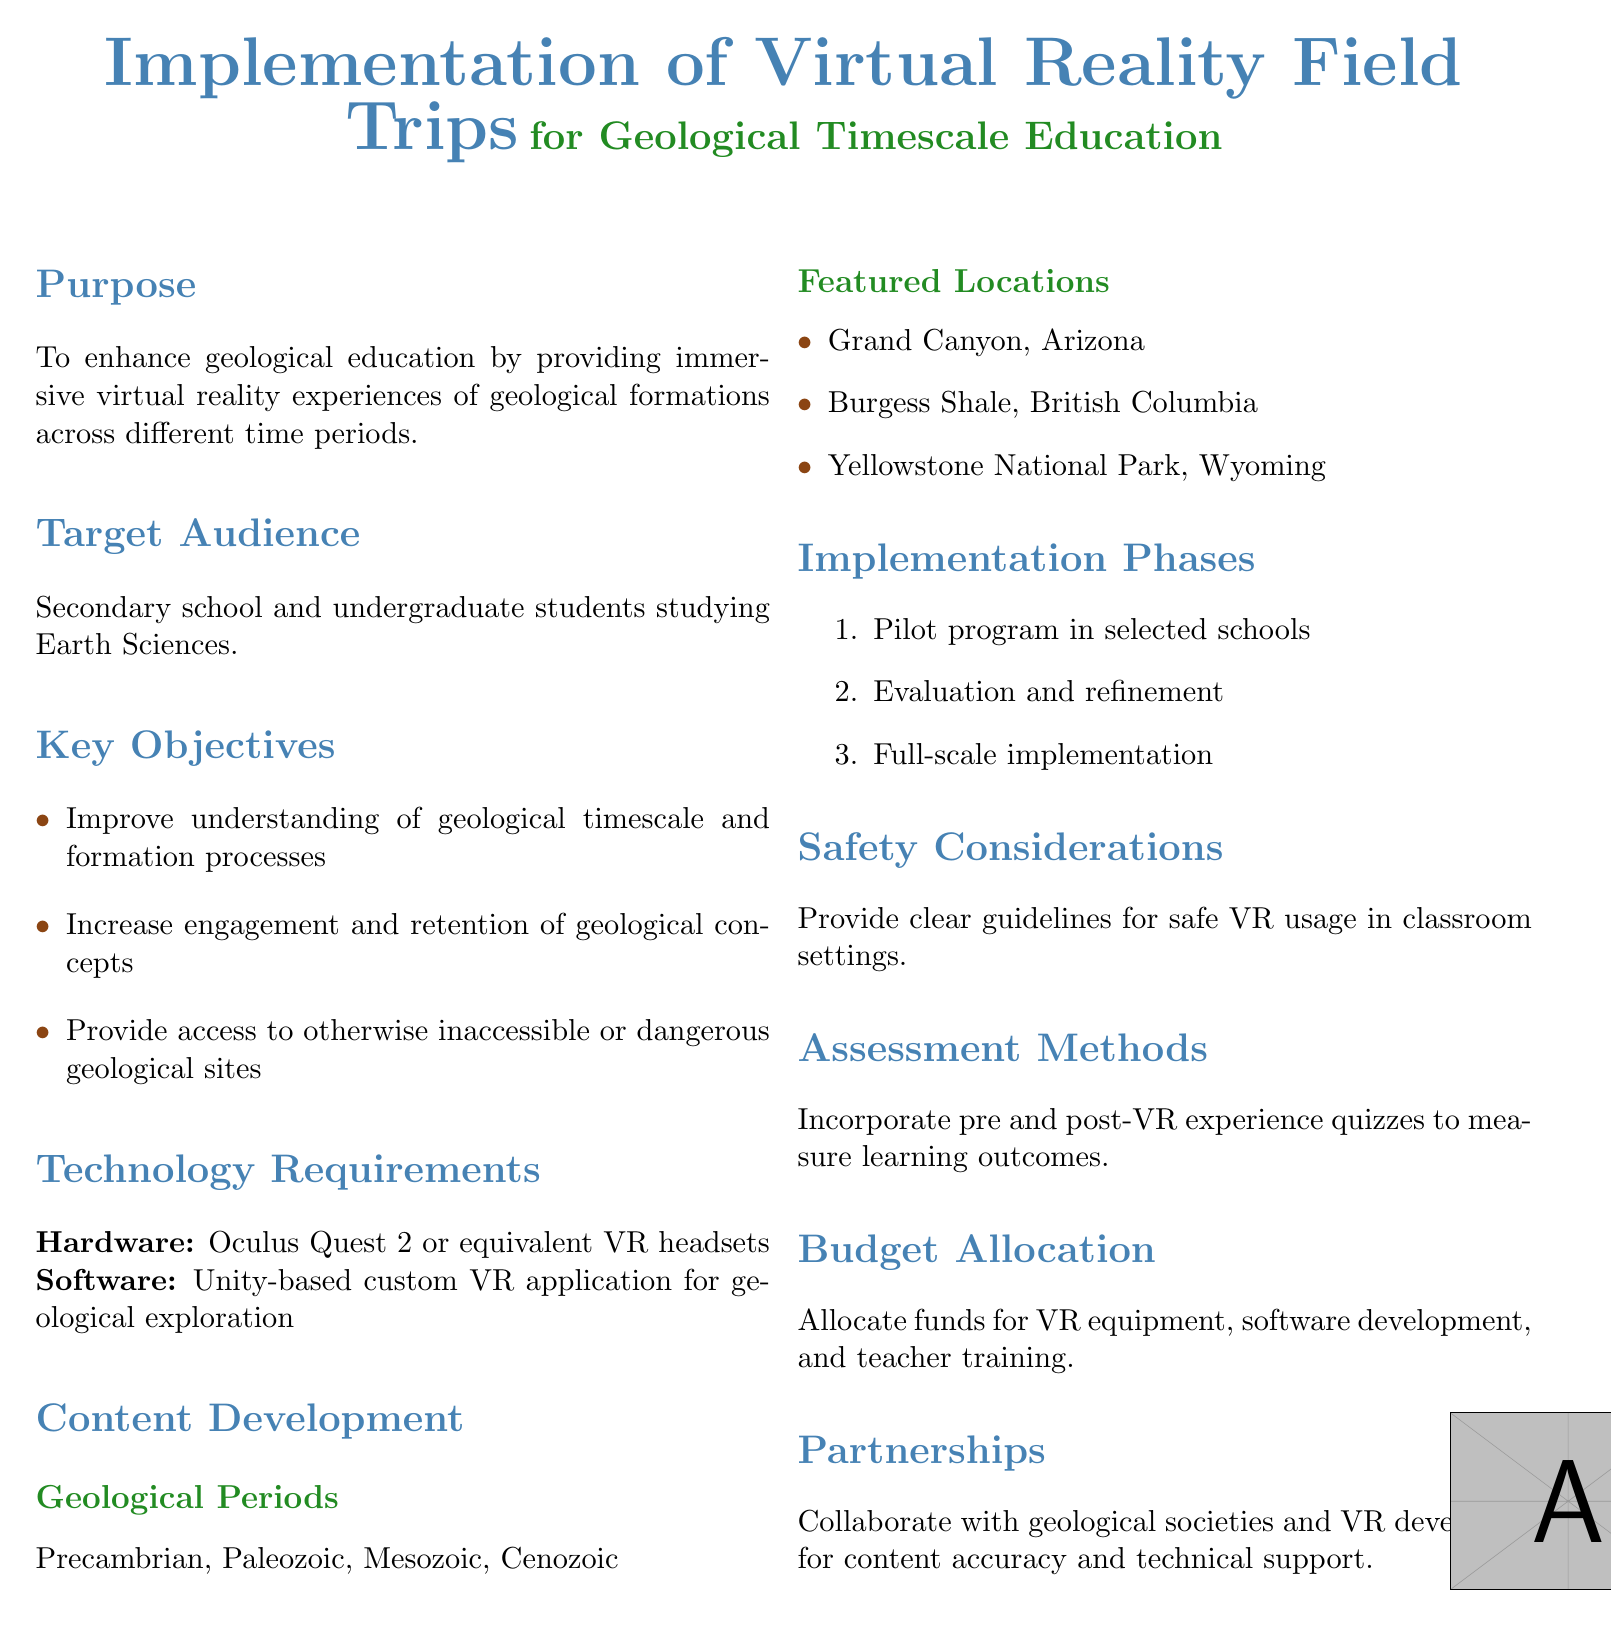What is the main purpose of the document? The main purpose is to enhance geological education through immersive experiences.
Answer: Enhance geological education Who is the target audience for this policy? The target audience is specified as secondary school and undergraduate students studying Earth Sciences.
Answer: Secondary school and undergraduate students What are the key objectives of this initiative? The key objectives include improving understanding and increasing engagement with geological concepts.
Answer: Improve understanding and increase engagement What type of hardware is required for the VR experience? The document mentions Oculus Quest 2 or equivalent VR headsets as the required hardware.
Answer: Oculus Quest 2 What is the name of one featured location in the virtual reality field trips? One featured location mentioned is the Grand Canyon, Arizona.
Answer: Grand Canyon, Arizona How many implementation phases are outlined in the document? The document outlines three implementation phases.
Answer: Three What type of assessments will be included? The assessments will include pre and post-VR experience quizzes to measure learning outcomes.
Answer: Pre and post-VR quizzes What is one safety consideration mentioned in the document? The document indicates the need for clear guidelines for safe VR usage.
Answer: Clear guidelines for safe VR usage Which software platform is used for the custom VR application? The software required is a Unity-based custom VR application.
Answer: Unity-based custom VR application 